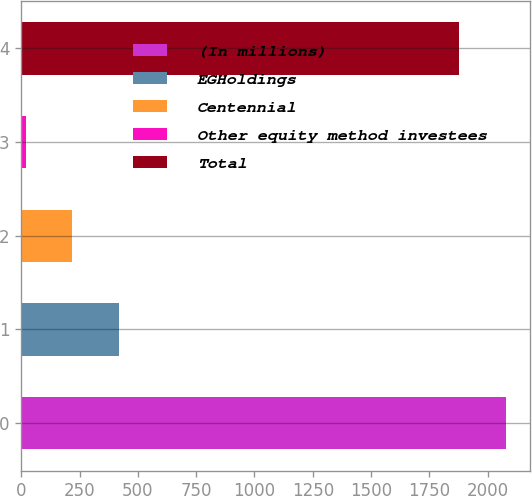Convert chart. <chart><loc_0><loc_0><loc_500><loc_500><bar_chart><fcel>(In millions)<fcel>EGHoldings<fcel>Centennial<fcel>Other equity method investees<fcel>Total<nl><fcel>2077.8<fcel>417.6<fcel>218.8<fcel>20<fcel>1879<nl></chart> 